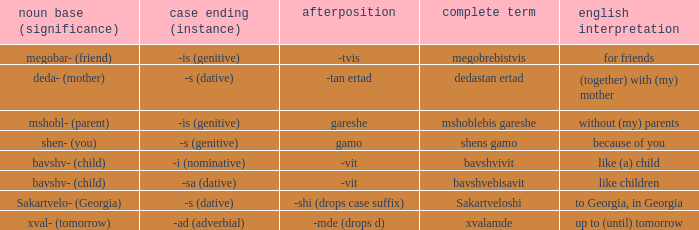What is English Meaning, when Full Word is "Shens Gamo"? Because of you. 